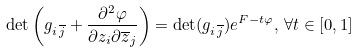Convert formula to latex. <formula><loc_0><loc_0><loc_500><loc_500>\det \left ( g _ { i \, \overline { j } } + \frac { \partial ^ { 2 } \varphi } { \partial z _ { i } \partial \overline { z } _ { j } } \right ) = \det ( g _ { i \, \overline { j } } ) e ^ { F - t \varphi } , \, \forall t \in [ 0 , 1 ]</formula> 